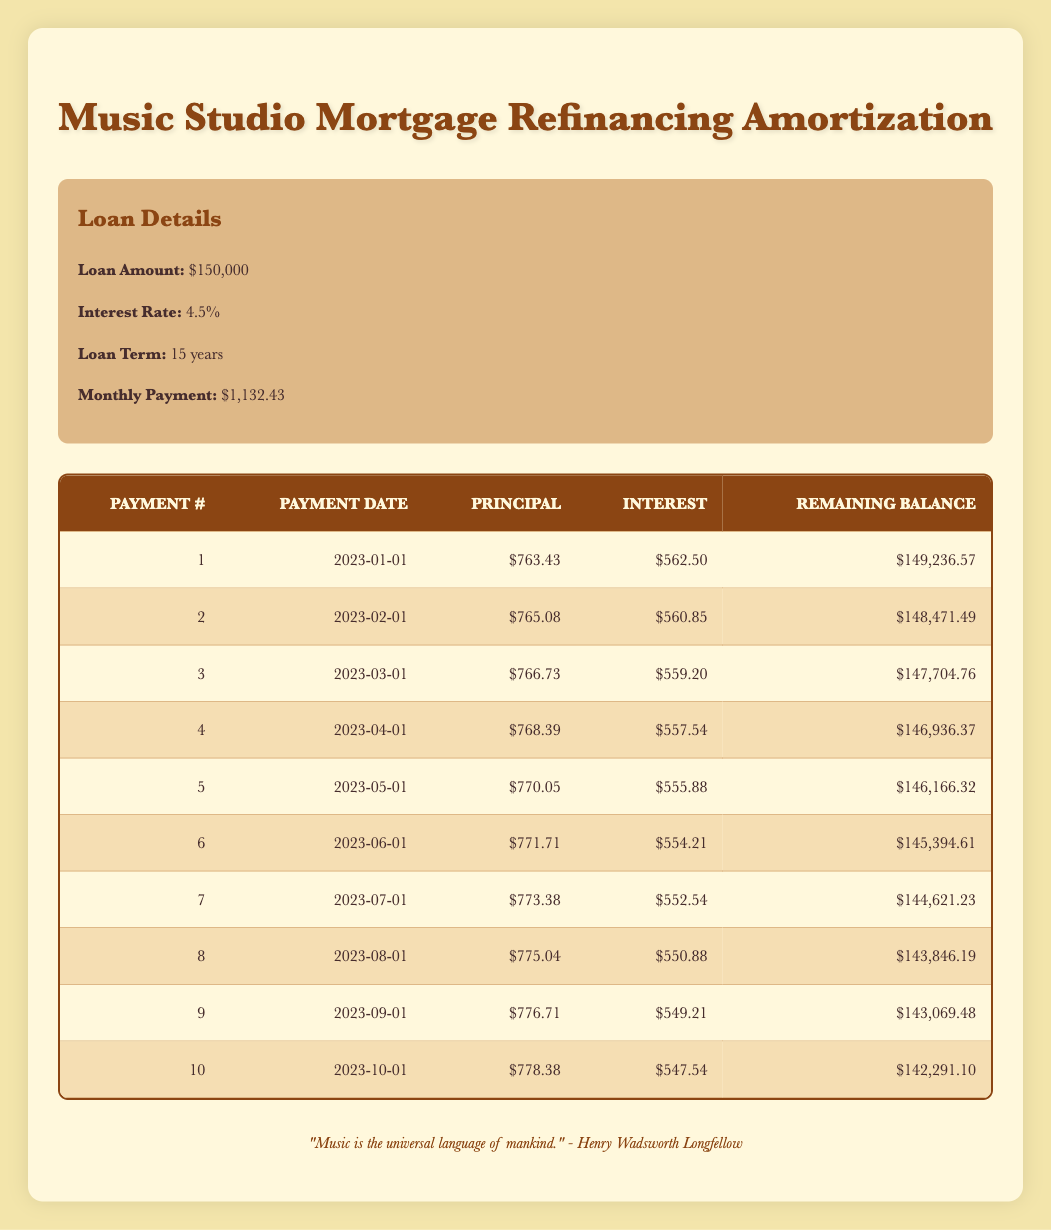What is the monthly payment amount for the mortgage? You can find the monthly payment amount in the loan details section. It is stated clearly as $1,132.43.
Answer: 1,132.43 How much principal was paid in the first payment? The principal payment for the first payment is listed in the first row of the payment schedule table, which shows $763.43.
Answer: 763.43 What is the remaining balance after the fifth payment? The remaining balance after the fifth payment can be found in the payment schedule table, which shows $146,166.32 in the fifth row.
Answer: 146,166.32 Is the interest payment for the third payment greater than the interest payment for the second payment? The interest payment for the third payment is $559.20 and for the second payment is $560.85. Since $559.20 is less than $560.85, the statement is false.
Answer: No What is the total principal paid after the first three payments? To find the total principal paid after the first three payments, sum the principal payments from the first three rows: $763.43 + $765.08 + $766.73 = $2,295.24.
Answer: 2,295.24 How much has the remaining balance decreased after the first payment? The remaining balance before the first payment was $150,000. After the first payment, it is $149,236.57. The decrease is $150,000 - $149,236.57 = $763.43.
Answer: 763.43 What is the average interest payment for the first ten months? The interest payments for the first ten months can be summed as: $562.50 + $560.85 + $559.20 + $557.54 + $555.88 + $554.21 + $552.54 + $550.88 + $549.21 + $547.54 = $5,464.41. There are ten payments, so the average is $5,464.41 / 10 = $546.44.
Answer: 546.44 What is the principal payment for the tenth payment? The principal payment for the tenth payment is found in the payment schedule table, specifically in the tenth row, which shows $778.38.
Answer: 778.38 Did the interest payment decrease from the first month to the second month? The interest payment for the first month is $562.50, and for the second month, it is $560.85. Since $562.50 is greater than $560.85, the interest payment did decrease.
Answer: Yes 